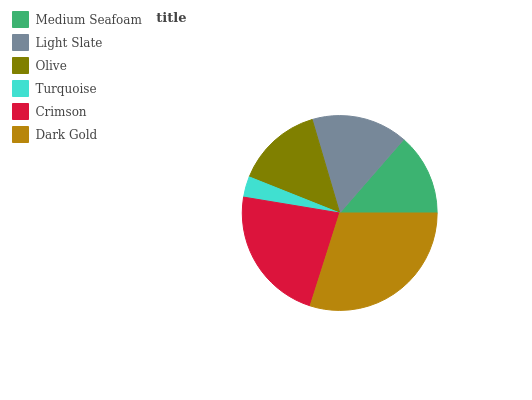Is Turquoise the minimum?
Answer yes or no. Yes. Is Dark Gold the maximum?
Answer yes or no. Yes. Is Light Slate the minimum?
Answer yes or no. No. Is Light Slate the maximum?
Answer yes or no. No. Is Light Slate greater than Medium Seafoam?
Answer yes or no. Yes. Is Medium Seafoam less than Light Slate?
Answer yes or no. Yes. Is Medium Seafoam greater than Light Slate?
Answer yes or no. No. Is Light Slate less than Medium Seafoam?
Answer yes or no. No. Is Light Slate the high median?
Answer yes or no. Yes. Is Olive the low median?
Answer yes or no. Yes. Is Dark Gold the high median?
Answer yes or no. No. Is Turquoise the low median?
Answer yes or no. No. 